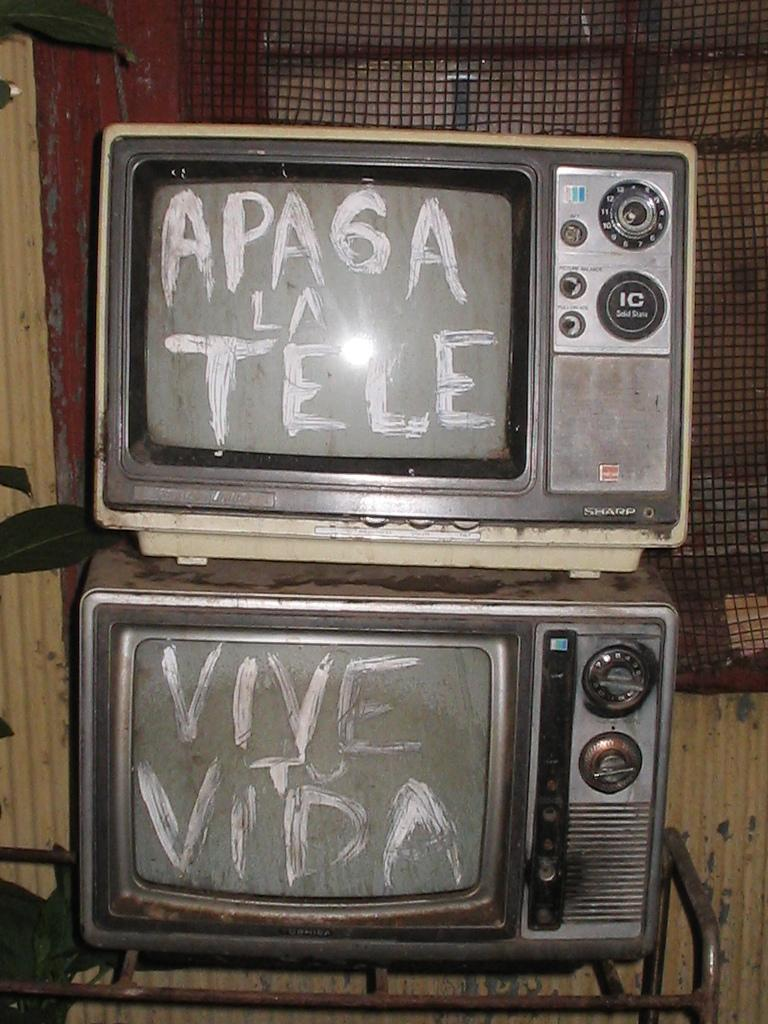<image>
Describe the image concisely. Someone has written Apaga La Tele and Vive To Vida on these televisions. 